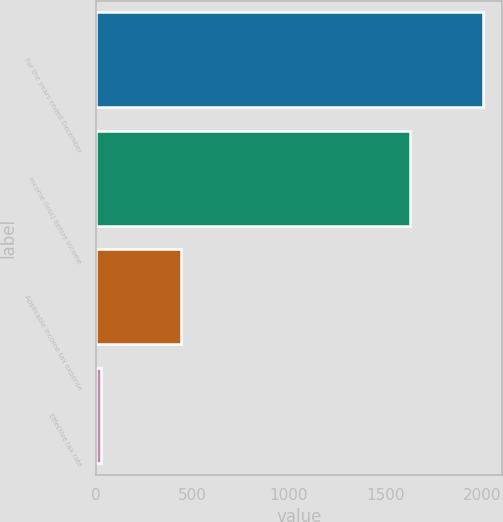Convert chart. <chart><loc_0><loc_0><loc_500><loc_500><bar_chart><fcel>For the years ended December<fcel>Income (loss) before income<fcel>Applicable income tax expense<fcel>Effective tax rate<nl><fcel>2006<fcel>1627<fcel>443<fcel>27.2<nl></chart> 